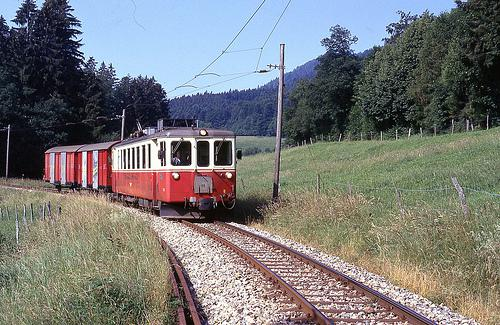Question: how many train cars are there?
Choices:
A. Four.
B. Three.
C. One.
D. Two.
Answer with the letter. Answer: B Question: when in the day is this?
Choices:
A. Afternoon.
B. When it's daylight.
C. Morning.
D. Dawn.
Answer with the letter. Answer: B Question: what is the train on?
Choices:
A. Railway.
B. The ground.
C. Train tracks.
D. The bridge.
Answer with the letter. Answer: C Question: where are the train tracks?
Choices:
A. On the ground.
B. On the bridge.
C. Crossing the mountain.
D. Under the train.
Answer with the letter. Answer: D 